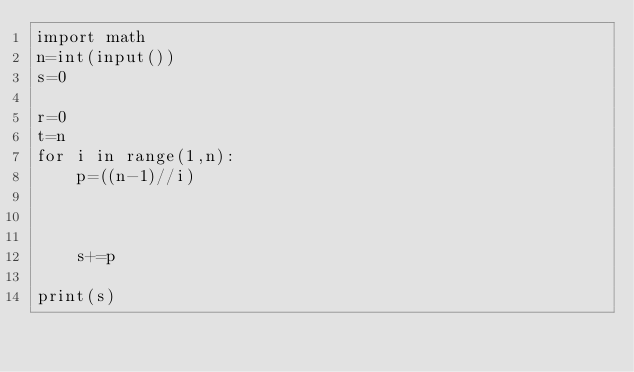<code> <loc_0><loc_0><loc_500><loc_500><_Python_>import math
n=int(input())
s=0

r=0
t=n
for i in range(1,n):
    p=((n-1)//i)



    s+=p

print(s)
</code> 